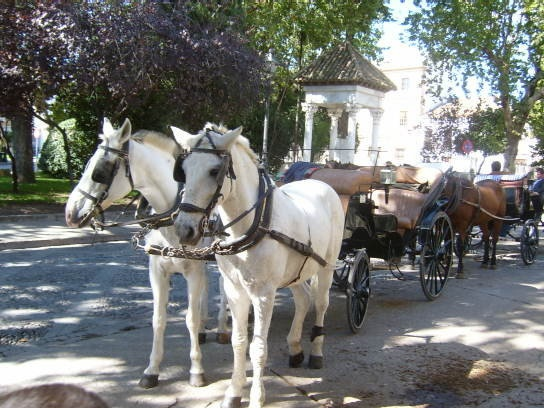Describe the objects in this image and their specific colors. I can see horse in black, darkgray, lightgray, and gray tones, horse in black, darkgray, lightgray, and gray tones, horse in black, gray, and maroon tones, people in black, gray, navy, and darkgray tones, and people in black, gray, and darkgray tones in this image. 